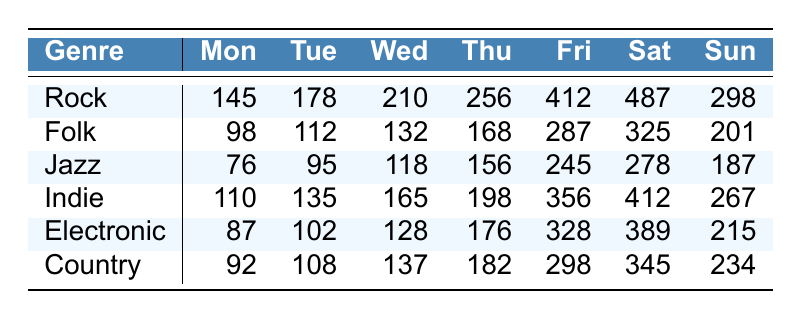What is the highest concert attendance for Rock? The table shows that the highest attendance for Rock occurs on Saturday with 487 attendees.
Answer: 487 On which day is the attendance for Jazz the lowest? Looking at the Jazz row, the lowest attendance is recorded on Monday, with 76 attendees.
Answer: Monday What is the total attendance for Folk across all days? To calculate the total for Folk, we sum the values: 98 + 112 + 132 + 168 + 287 + 325 + 201 = 1323.
Answer: 1323 Which genre has the highest attendance on Fridays? The attendance for Friday shows Rock has 412, Indie has 356, Folk has 287, Jazz has 245, Electronic has 328, and Country has 298. Rock has the highest attendance.
Answer: Rock Are there any genres where Sunday attendance exceeds 250? By checking the Sunday column, Rock has 298, Indie has 267, and Country has 234. Yes, Rock and Indie exceed 250.
Answer: Yes What is the average attendance for Electronic on weekdays (Monday to Thursday)? The attendance on weekdays for Electronic is: (87 + 102 + 128 + 176) = 493. The average is 493 / 4 = 123.25.
Answer: 123.25 What is the difference in attendance between the highest genre and the lowest genre on Wednesdays? Rock has 210 and Jazz has 118 on Wednesdays. The difference is 210 - 118 = 92.
Answer: 92 Which genre has the closest attendance to 300 on Saturdays? On Saturday, Rock has 487, Folk has 325, Jazz has 278, Indie has 412, Electronic has 389, and Country has 345. Folk has the closest attendance to 300.
Answer: Folk How many more attendees did Indie have compared to Folk on Thursdays? Indie has 198 and Folk has 168 on Thursdays. The difference is 198 - 168 = 30 attendees.
Answer: 30 Which day has the overall highest total attendance across all genres? Adding the attendance for each day: Mon: 145+98+76+110+87+92=608, Tue: 178+112+95+135+102+108=730, Wed: 210+132+118+165+128+137=890, Thu: 256+168+156+198+176+182=936, Fri: 412+287+245+356+328+298=1926, Sat: 487+325+278+412+389+345=2234, Sun: 298+201+187+267+215+234=1404. Saturday has the highest total attendance of 2234.
Answer: Saturday 